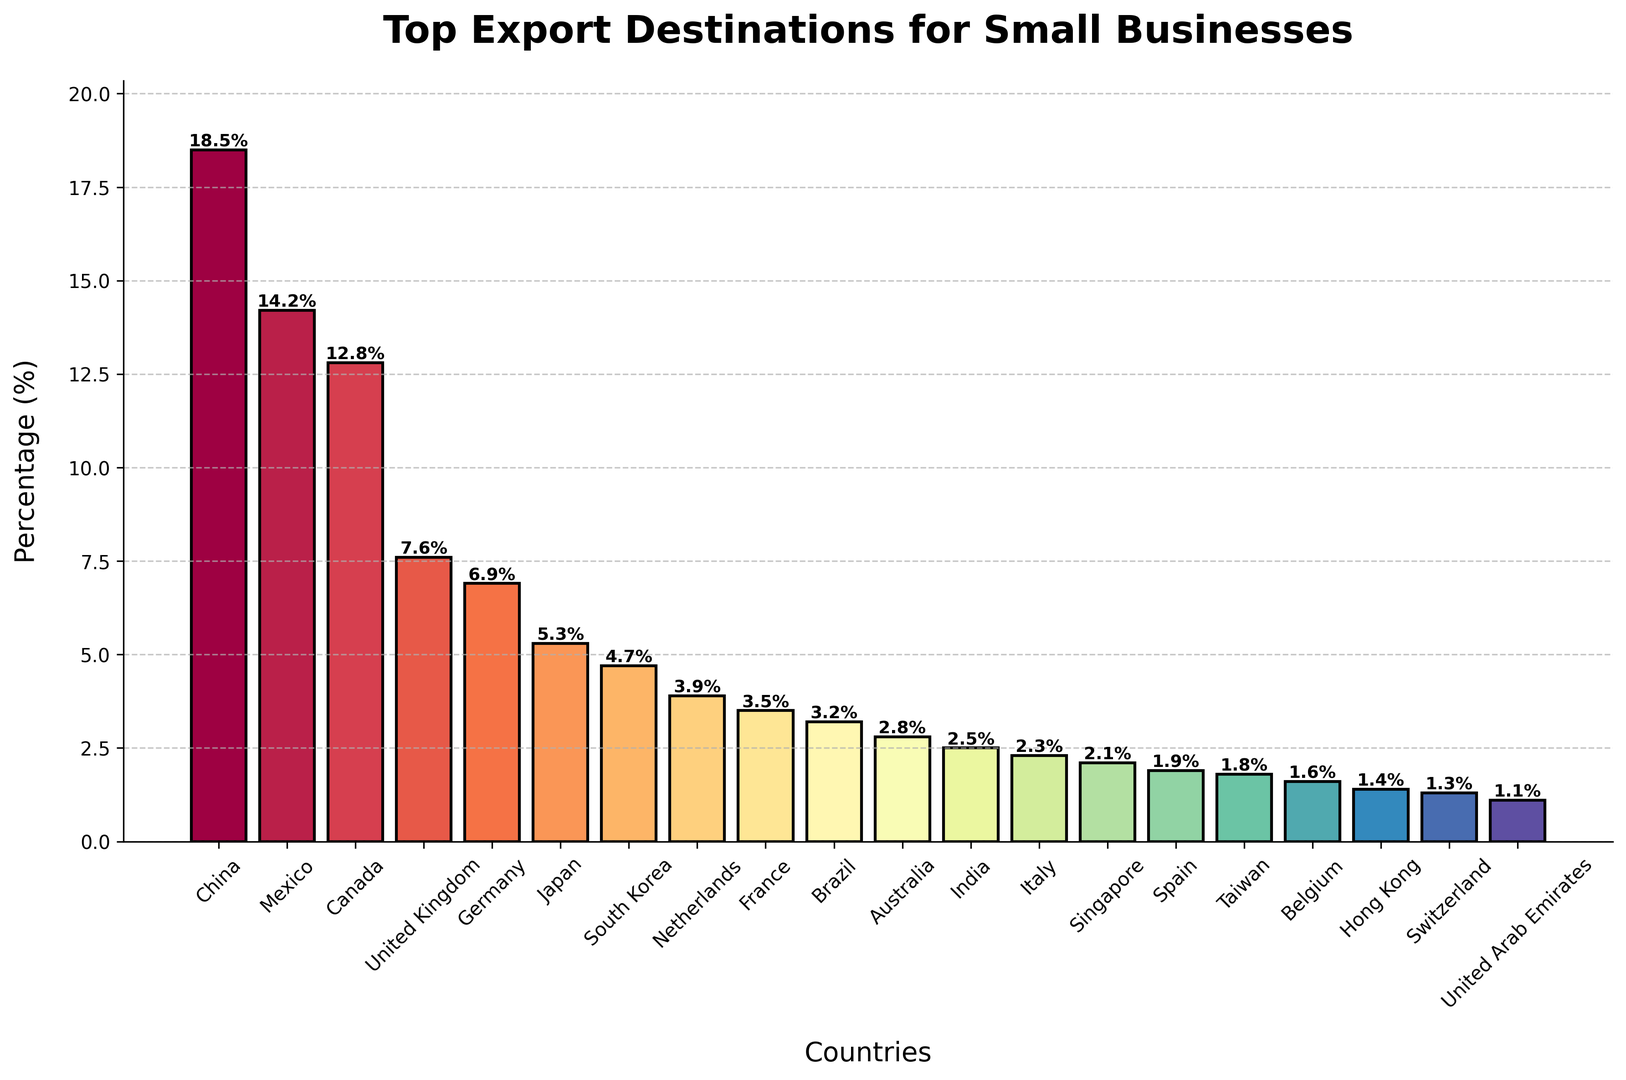Which country is the top export destination for small businesses? By looking at the bar chart, the country with the tallest bar is the top export destination. In this case, the tallest bar corresponds to China.
Answer: China What are the percentages of exports to China and Mexico? By referring to the top two bars from the left, China has a percentage of 18.5% and Mexico has a percentage of 14.2%.
Answer: 18.5% and 14.2% How much higher is the percentage of exports to China compared to Canada? China has a percentage of 18.5%, and Canada has 12.8%. Subtracting Canada's percentage from China's percentage gives 18.5% - 12.8% = 5.7%.
Answer: 5.7% Which two countries have the closest export percentages? By examining the heights of the bars and comparing the percentages, the closest export percentages are for India (2.5%) and Italy (2.3%).
Answer: India and Italy What is the combined percentage of exports to the United Kingdom, Germany, and Japan? Add the percentages for the United Kingdom (7.6%), Germany (6.9%), and Japan (5.3%). This gives 7.6% + 6.9% + 5.3% = 19.8%.
Answer: 19.8% Which country has a higher percentage of exports, Brazil or Australia? By comparing the heights of the bars for Brazil (3.2%) and Australia (2.8%), we see that Brazil's bar is higher.
Answer: Brazil Is the percentage of exports to South Korea higher or lower than to the Netherlands? South Korea has a percentage of 4.7%, and the Netherlands has 3.9%. Comparing the two values, South Korea is higher.
Answer: Higher What is the difference in export percentages between Italy and Taiwan? Italy has a percentage of 2.3%, and Taiwan has 1.8%. Subtracting Taiwan's percentage from Italy's gives 2.3% - 1.8% = 0.5%.
Answer: 0.5% Which country has the lowest export percentage, and what is it? The country with the shortest bar represents the lowest percentage, which is the United Arab Emirates with 1.1%.
Answer: United Arab Emirates, 1.1% 